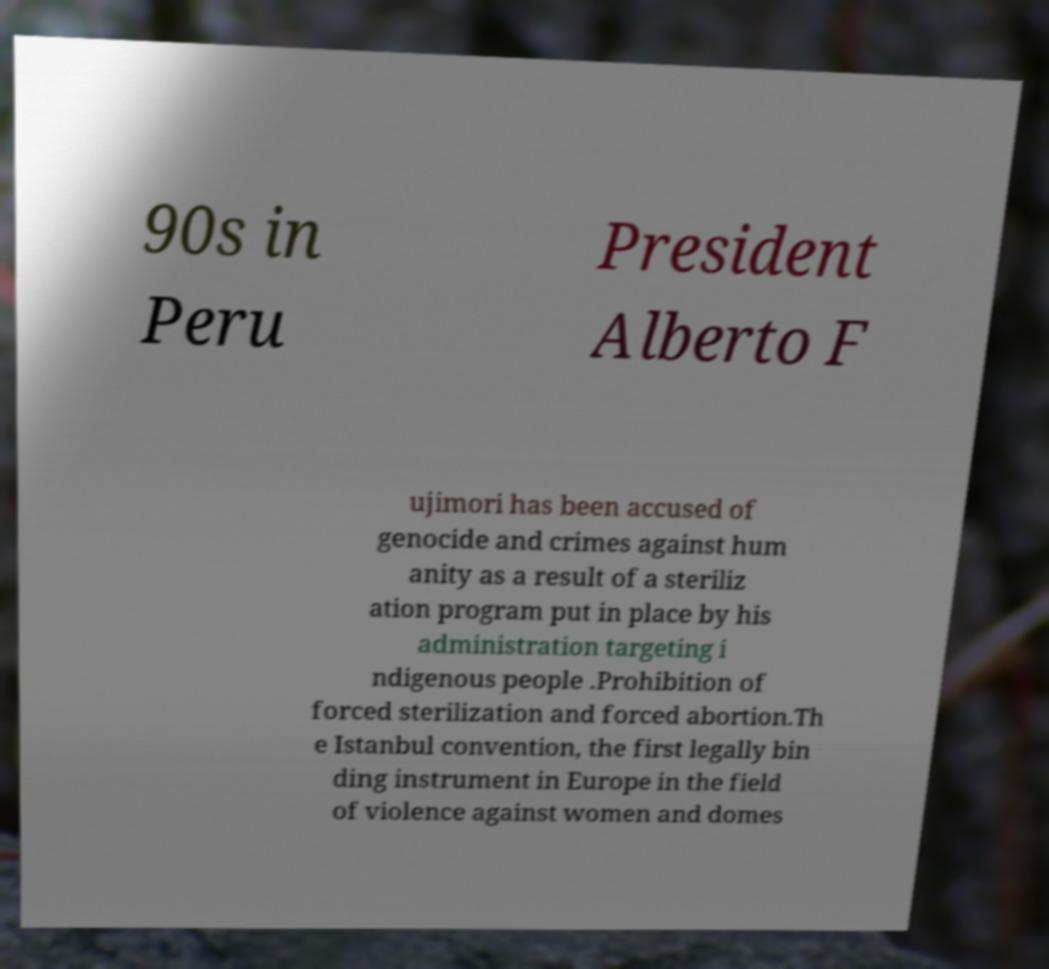Could you assist in decoding the text presented in this image and type it out clearly? 90s in Peru President Alberto F ujimori has been accused of genocide and crimes against hum anity as a result of a steriliz ation program put in place by his administration targeting i ndigenous people .Prohibition of forced sterilization and forced abortion.Th e Istanbul convention, the first legally bin ding instrument in Europe in the field of violence against women and domes 